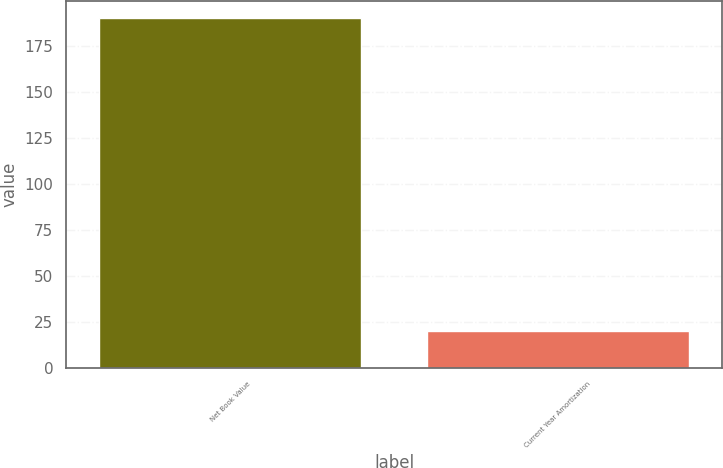<chart> <loc_0><loc_0><loc_500><loc_500><bar_chart><fcel>Net Book Value<fcel>Current Year Amortization<nl><fcel>190<fcel>20<nl></chart> 